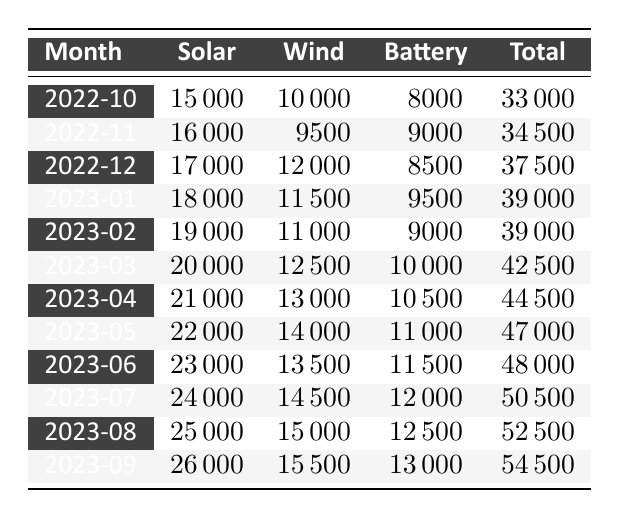What was the total copper demand in September 2023? In September 2023, the table shows the total demand under the "Total" column, which is 54,500.
Answer: 54,500 How much was the solar energy demand in March 2023? The table indicates that the solar energy demand for March 2023 is listed in the "Solar" column as 20,000.
Answer: 20,000 What is the total demand for copper from renewable energy sectors over the last three months (July, August, September 2023)? To find the total demand over these months, sum the total values: July (50,500) + August (52,500) + September (54,500). This gives us 50,500 + 52,500 + 54,500 = 157,500.
Answer: 157,500 Is the wind energy demand in June 2023 greater than in April 2023? Looking at the "Wind" column, June 2023 shows a demand of 13,500 and April 2023 shows a demand of 13,000. Since 13,500 is greater than 13,000, the statement is true.
Answer: Yes What was the average battery storage demand from October 2022 to September 2023? To calculate the average, first sum the battery storage demands for each month: 8000 + 9000 + 8500 + 9500 + 9000 + 10000 + 10500 + 11000 + 11500 + 12000 + 12500 + 13000 = 123000. There are 12 months, so the average is 123000 / 12 = 10250.
Answer: 10,250 What was the increase in total copper demand from October 2022 to September 2023? The total demand in October 2022 was 33,000 and in September 2023 was 54,500. The increase is calculated as 54,500 - 33,000 = 21,500.
Answer: 21,500 Was there a month in which the solar energy demand reached or exceeded 25,000? Checking the "Solar" column, the demand exceeds 25,000 only in August and September 2023. Thus, the statement is true.
Answer: Yes Which month had the highest demand for battery storage, and what was the value? The maximum battery storage demand appears in July 2023 with a value of 12,000 in the "Battery" column.
Answer: July 2023, 12,000 Compare the total demand in December 2022 and January 2023. Which month had higher demand? The total demand for December 2022 is 37,500 and for January 2023 it is 39,000. Since 39,000 is greater than 37,500, January 2023 had higher demand.
Answer: January 2023 had higher demand 